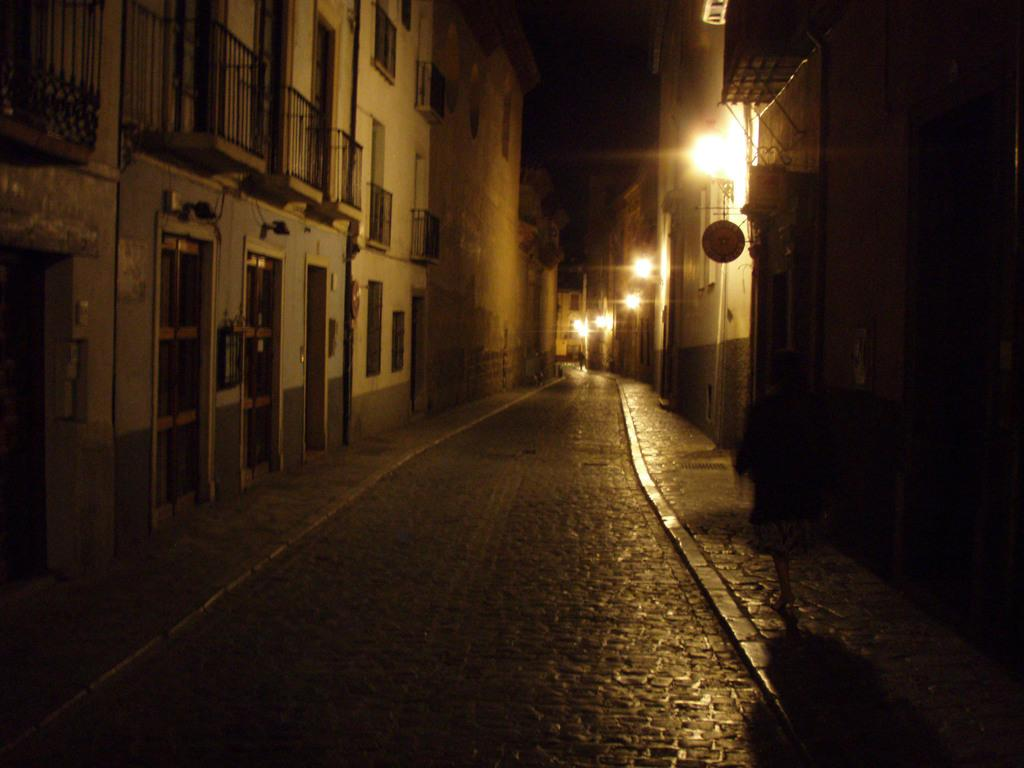What type of structures can be seen in the image? There are buildings in the image. What objects are used for cooking in the image? There are grills in the image. What type of infrastructure is present in the image? There are pipelines in the image. What type of lighting is present in the image? There are street lights in the image. What type of pathway is visible in the image? There is a road in the image. How many pets are visible in the image? There are no pets present in the image. What type of respect can be seen in the image? There is no indication of respect in the image; it features buildings, grills, pipelines, street lights, and a road. 